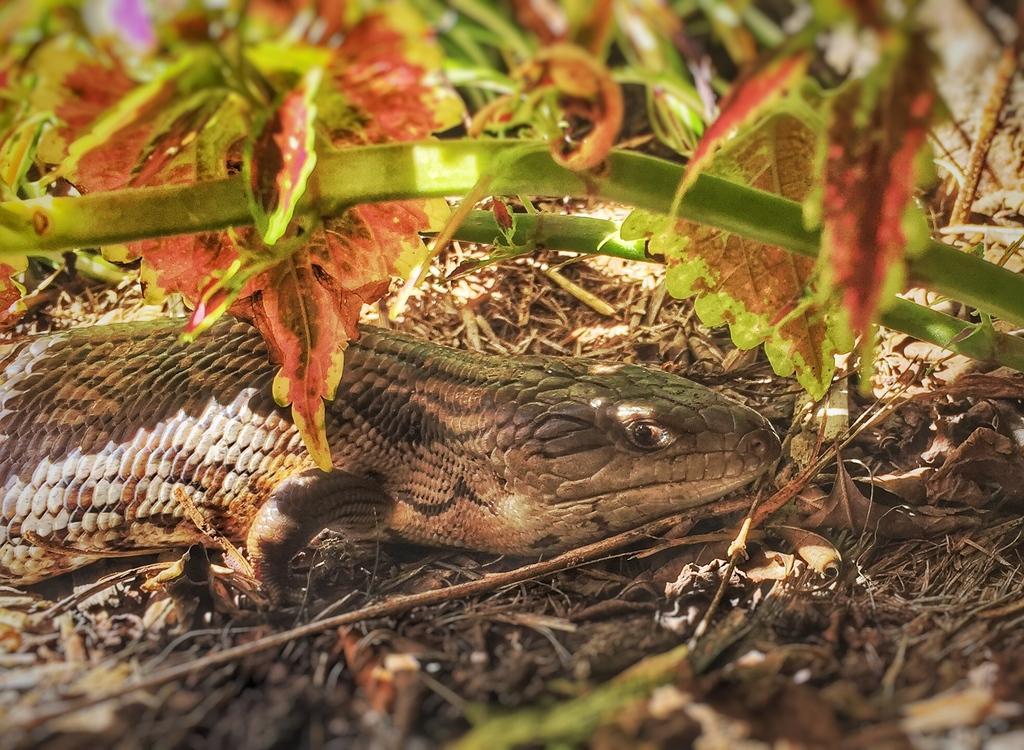Please provide a concise description of this image. In this picture we can see a reptile in the middle, there are some leaves in the front. 